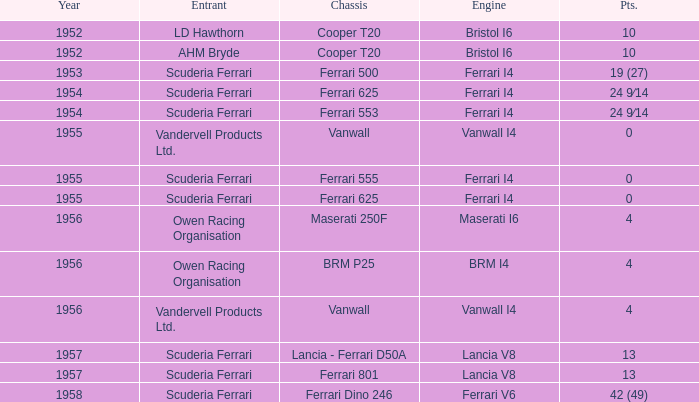Who is the contender when the year is before 1953? LD Hawthorn, AHM Bryde. 